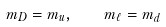Convert formula to latex. <formula><loc_0><loc_0><loc_500><loc_500>m _ { D } = m _ { u } , \quad m _ { \ell } = m _ { d }</formula> 